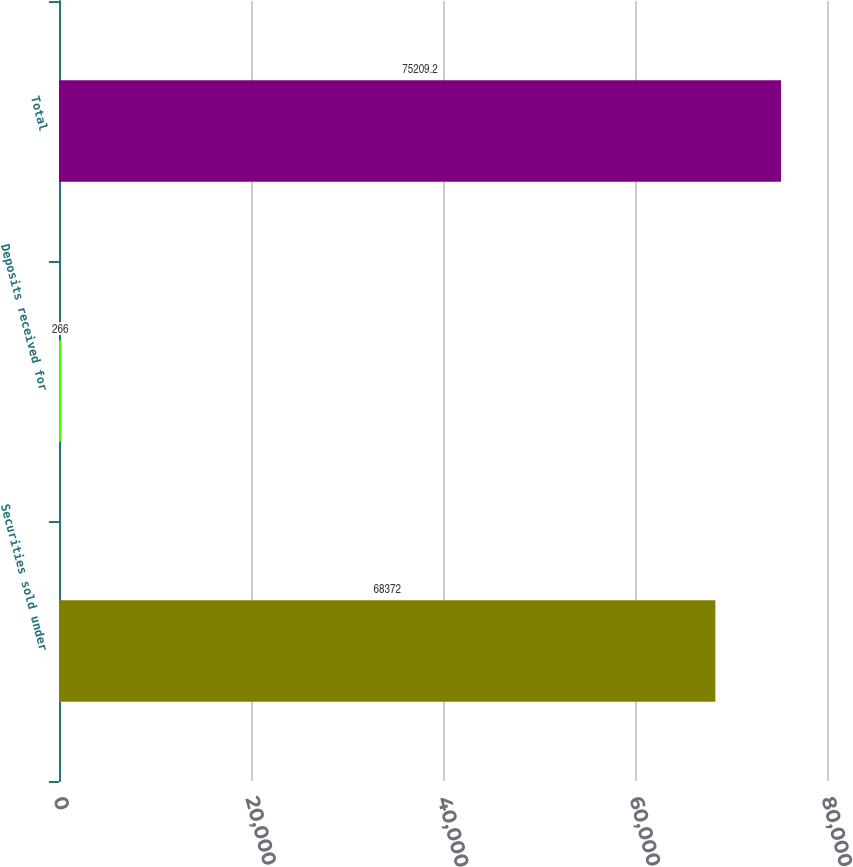Convert chart to OTSL. <chart><loc_0><loc_0><loc_500><loc_500><bar_chart><fcel>Securities sold under<fcel>Deposits received for<fcel>Total<nl><fcel>68372<fcel>266<fcel>75209.2<nl></chart> 